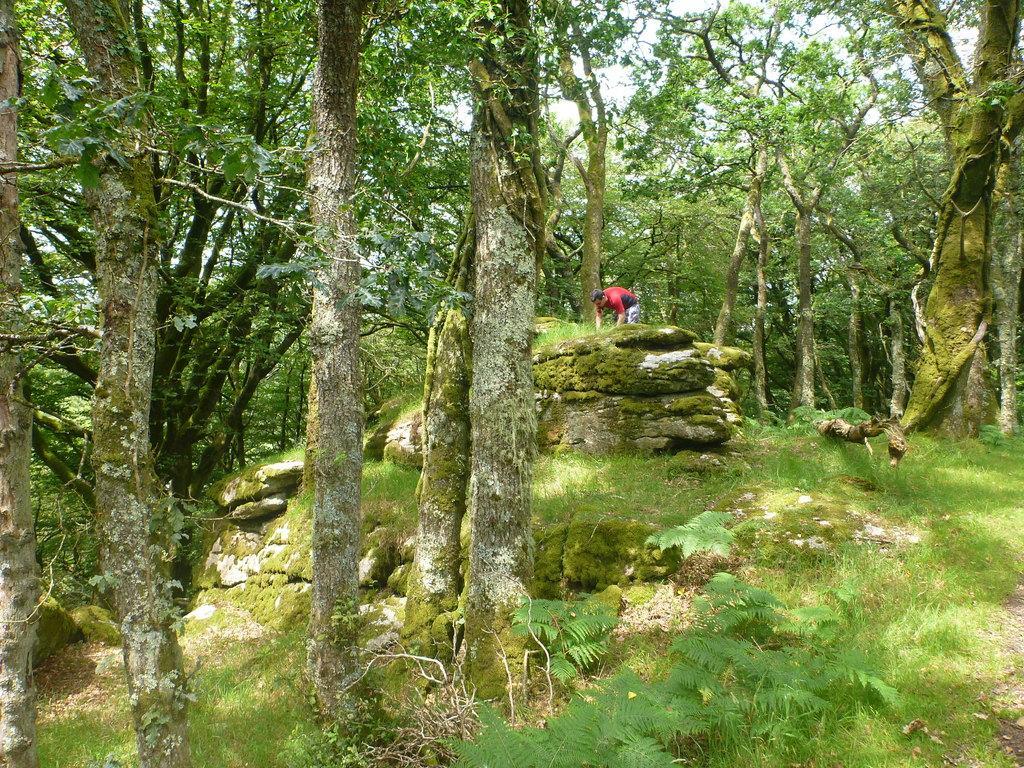In one or two sentences, can you explain what this image depicts? Land is covered with grass. Here we can see plants, trees and a person. 